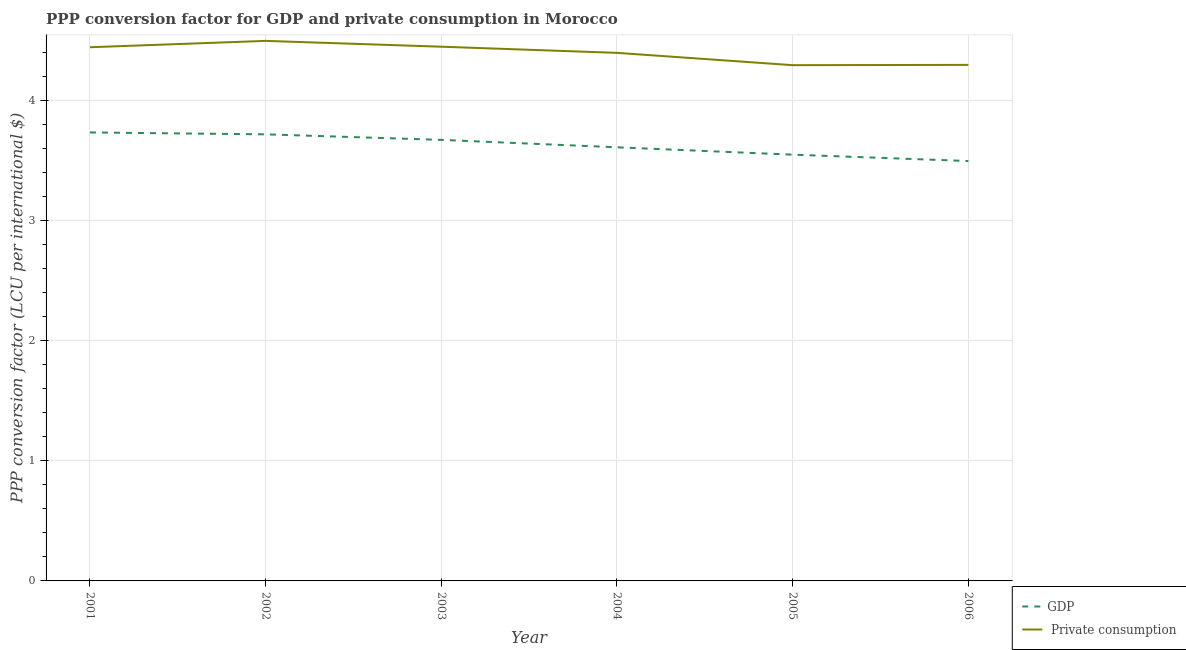How many different coloured lines are there?
Give a very brief answer. 2. Does the line corresponding to ppp conversion factor for private consumption intersect with the line corresponding to ppp conversion factor for gdp?
Offer a terse response. No. Is the number of lines equal to the number of legend labels?
Keep it short and to the point. Yes. What is the ppp conversion factor for private consumption in 2002?
Keep it short and to the point. 4.49. Across all years, what is the maximum ppp conversion factor for private consumption?
Make the answer very short. 4.49. Across all years, what is the minimum ppp conversion factor for private consumption?
Provide a short and direct response. 4.29. In which year was the ppp conversion factor for private consumption maximum?
Offer a very short reply. 2002. What is the total ppp conversion factor for private consumption in the graph?
Make the answer very short. 26.37. What is the difference between the ppp conversion factor for private consumption in 2003 and that in 2004?
Offer a terse response. 0.05. What is the difference between the ppp conversion factor for private consumption in 2004 and the ppp conversion factor for gdp in 2006?
Provide a succinct answer. 0.9. What is the average ppp conversion factor for private consumption per year?
Give a very brief answer. 4.39. In the year 2003, what is the difference between the ppp conversion factor for gdp and ppp conversion factor for private consumption?
Keep it short and to the point. -0.78. What is the ratio of the ppp conversion factor for gdp in 2001 to that in 2006?
Your response must be concise. 1.07. Is the ppp conversion factor for gdp in 2001 less than that in 2003?
Your answer should be very brief. No. Is the difference between the ppp conversion factor for private consumption in 2003 and 2005 greater than the difference between the ppp conversion factor for gdp in 2003 and 2005?
Provide a succinct answer. Yes. What is the difference between the highest and the second highest ppp conversion factor for private consumption?
Your answer should be very brief. 0.05. What is the difference between the highest and the lowest ppp conversion factor for gdp?
Provide a succinct answer. 0.24. Does the ppp conversion factor for private consumption monotonically increase over the years?
Your answer should be very brief. No. What is the difference between two consecutive major ticks on the Y-axis?
Offer a very short reply. 1. Are the values on the major ticks of Y-axis written in scientific E-notation?
Your answer should be compact. No. Does the graph contain any zero values?
Offer a terse response. No. How many legend labels are there?
Provide a succinct answer. 2. How are the legend labels stacked?
Your response must be concise. Vertical. What is the title of the graph?
Your answer should be compact. PPP conversion factor for GDP and private consumption in Morocco. Does "Research and Development" appear as one of the legend labels in the graph?
Keep it short and to the point. No. What is the label or title of the X-axis?
Offer a terse response. Year. What is the label or title of the Y-axis?
Your response must be concise. PPP conversion factor (LCU per international $). What is the PPP conversion factor (LCU per international $) of GDP in 2001?
Keep it short and to the point. 3.73. What is the PPP conversion factor (LCU per international $) in  Private consumption in 2001?
Offer a very short reply. 4.44. What is the PPP conversion factor (LCU per international $) of GDP in 2002?
Your answer should be compact. 3.72. What is the PPP conversion factor (LCU per international $) of  Private consumption in 2002?
Provide a succinct answer. 4.49. What is the PPP conversion factor (LCU per international $) in GDP in 2003?
Offer a terse response. 3.67. What is the PPP conversion factor (LCU per international $) of  Private consumption in 2003?
Your response must be concise. 4.45. What is the PPP conversion factor (LCU per international $) of GDP in 2004?
Provide a succinct answer. 3.61. What is the PPP conversion factor (LCU per international $) of  Private consumption in 2004?
Your answer should be very brief. 4.4. What is the PPP conversion factor (LCU per international $) in GDP in 2005?
Offer a terse response. 3.55. What is the PPP conversion factor (LCU per international $) of  Private consumption in 2005?
Your answer should be very brief. 4.29. What is the PPP conversion factor (LCU per international $) in GDP in 2006?
Ensure brevity in your answer.  3.49. What is the PPP conversion factor (LCU per international $) in  Private consumption in 2006?
Your answer should be very brief. 4.3. Across all years, what is the maximum PPP conversion factor (LCU per international $) in GDP?
Make the answer very short. 3.73. Across all years, what is the maximum PPP conversion factor (LCU per international $) of  Private consumption?
Keep it short and to the point. 4.49. Across all years, what is the minimum PPP conversion factor (LCU per international $) of GDP?
Give a very brief answer. 3.49. Across all years, what is the minimum PPP conversion factor (LCU per international $) of  Private consumption?
Ensure brevity in your answer.  4.29. What is the total PPP conversion factor (LCU per international $) of GDP in the graph?
Make the answer very short. 21.77. What is the total PPP conversion factor (LCU per international $) of  Private consumption in the graph?
Your answer should be very brief. 26.37. What is the difference between the PPP conversion factor (LCU per international $) of GDP in 2001 and that in 2002?
Make the answer very short. 0.02. What is the difference between the PPP conversion factor (LCU per international $) in  Private consumption in 2001 and that in 2002?
Make the answer very short. -0.05. What is the difference between the PPP conversion factor (LCU per international $) in GDP in 2001 and that in 2003?
Make the answer very short. 0.06. What is the difference between the PPP conversion factor (LCU per international $) of  Private consumption in 2001 and that in 2003?
Give a very brief answer. -0. What is the difference between the PPP conversion factor (LCU per international $) of GDP in 2001 and that in 2004?
Keep it short and to the point. 0.12. What is the difference between the PPP conversion factor (LCU per international $) in  Private consumption in 2001 and that in 2004?
Your response must be concise. 0.05. What is the difference between the PPP conversion factor (LCU per international $) in GDP in 2001 and that in 2005?
Provide a succinct answer. 0.18. What is the difference between the PPP conversion factor (LCU per international $) in  Private consumption in 2001 and that in 2005?
Provide a short and direct response. 0.15. What is the difference between the PPP conversion factor (LCU per international $) of GDP in 2001 and that in 2006?
Make the answer very short. 0.24. What is the difference between the PPP conversion factor (LCU per international $) of  Private consumption in 2001 and that in 2006?
Offer a terse response. 0.15. What is the difference between the PPP conversion factor (LCU per international $) of GDP in 2002 and that in 2003?
Provide a short and direct response. 0.05. What is the difference between the PPP conversion factor (LCU per international $) in  Private consumption in 2002 and that in 2003?
Your answer should be very brief. 0.05. What is the difference between the PPP conversion factor (LCU per international $) in GDP in 2002 and that in 2004?
Provide a short and direct response. 0.11. What is the difference between the PPP conversion factor (LCU per international $) in  Private consumption in 2002 and that in 2004?
Provide a short and direct response. 0.1. What is the difference between the PPP conversion factor (LCU per international $) in GDP in 2002 and that in 2005?
Your answer should be compact. 0.17. What is the difference between the PPP conversion factor (LCU per international $) of  Private consumption in 2002 and that in 2005?
Give a very brief answer. 0.2. What is the difference between the PPP conversion factor (LCU per international $) in GDP in 2002 and that in 2006?
Your answer should be very brief. 0.22. What is the difference between the PPP conversion factor (LCU per international $) of  Private consumption in 2002 and that in 2006?
Keep it short and to the point. 0.2. What is the difference between the PPP conversion factor (LCU per international $) in GDP in 2003 and that in 2004?
Your answer should be compact. 0.06. What is the difference between the PPP conversion factor (LCU per international $) in  Private consumption in 2003 and that in 2004?
Provide a short and direct response. 0.05. What is the difference between the PPP conversion factor (LCU per international $) of GDP in 2003 and that in 2005?
Offer a very short reply. 0.12. What is the difference between the PPP conversion factor (LCU per international $) of  Private consumption in 2003 and that in 2005?
Ensure brevity in your answer.  0.15. What is the difference between the PPP conversion factor (LCU per international $) in GDP in 2003 and that in 2006?
Provide a short and direct response. 0.18. What is the difference between the PPP conversion factor (LCU per international $) in  Private consumption in 2003 and that in 2006?
Offer a terse response. 0.15. What is the difference between the PPP conversion factor (LCU per international $) of GDP in 2004 and that in 2005?
Provide a succinct answer. 0.06. What is the difference between the PPP conversion factor (LCU per international $) in  Private consumption in 2004 and that in 2005?
Your answer should be very brief. 0.1. What is the difference between the PPP conversion factor (LCU per international $) of GDP in 2004 and that in 2006?
Offer a very short reply. 0.11. What is the difference between the PPP conversion factor (LCU per international $) of GDP in 2005 and that in 2006?
Ensure brevity in your answer.  0.05. What is the difference between the PPP conversion factor (LCU per international $) in  Private consumption in 2005 and that in 2006?
Give a very brief answer. -0. What is the difference between the PPP conversion factor (LCU per international $) in GDP in 2001 and the PPP conversion factor (LCU per international $) in  Private consumption in 2002?
Provide a succinct answer. -0.76. What is the difference between the PPP conversion factor (LCU per international $) of GDP in 2001 and the PPP conversion factor (LCU per international $) of  Private consumption in 2003?
Offer a terse response. -0.71. What is the difference between the PPP conversion factor (LCU per international $) of GDP in 2001 and the PPP conversion factor (LCU per international $) of  Private consumption in 2004?
Keep it short and to the point. -0.66. What is the difference between the PPP conversion factor (LCU per international $) of GDP in 2001 and the PPP conversion factor (LCU per international $) of  Private consumption in 2005?
Provide a short and direct response. -0.56. What is the difference between the PPP conversion factor (LCU per international $) in GDP in 2001 and the PPP conversion factor (LCU per international $) in  Private consumption in 2006?
Offer a very short reply. -0.56. What is the difference between the PPP conversion factor (LCU per international $) in GDP in 2002 and the PPP conversion factor (LCU per international $) in  Private consumption in 2003?
Give a very brief answer. -0.73. What is the difference between the PPP conversion factor (LCU per international $) in GDP in 2002 and the PPP conversion factor (LCU per international $) in  Private consumption in 2004?
Provide a succinct answer. -0.68. What is the difference between the PPP conversion factor (LCU per international $) in GDP in 2002 and the PPP conversion factor (LCU per international $) in  Private consumption in 2005?
Offer a very short reply. -0.58. What is the difference between the PPP conversion factor (LCU per international $) in GDP in 2002 and the PPP conversion factor (LCU per international $) in  Private consumption in 2006?
Keep it short and to the point. -0.58. What is the difference between the PPP conversion factor (LCU per international $) of GDP in 2003 and the PPP conversion factor (LCU per international $) of  Private consumption in 2004?
Offer a very short reply. -0.72. What is the difference between the PPP conversion factor (LCU per international $) of GDP in 2003 and the PPP conversion factor (LCU per international $) of  Private consumption in 2005?
Your answer should be compact. -0.62. What is the difference between the PPP conversion factor (LCU per international $) in GDP in 2003 and the PPP conversion factor (LCU per international $) in  Private consumption in 2006?
Keep it short and to the point. -0.62. What is the difference between the PPP conversion factor (LCU per international $) of GDP in 2004 and the PPP conversion factor (LCU per international $) of  Private consumption in 2005?
Give a very brief answer. -0.68. What is the difference between the PPP conversion factor (LCU per international $) in GDP in 2004 and the PPP conversion factor (LCU per international $) in  Private consumption in 2006?
Ensure brevity in your answer.  -0.69. What is the difference between the PPP conversion factor (LCU per international $) in GDP in 2005 and the PPP conversion factor (LCU per international $) in  Private consumption in 2006?
Give a very brief answer. -0.75. What is the average PPP conversion factor (LCU per international $) of GDP per year?
Offer a terse response. 3.63. What is the average PPP conversion factor (LCU per international $) in  Private consumption per year?
Your response must be concise. 4.39. In the year 2001, what is the difference between the PPP conversion factor (LCU per international $) in GDP and PPP conversion factor (LCU per international $) in  Private consumption?
Provide a succinct answer. -0.71. In the year 2002, what is the difference between the PPP conversion factor (LCU per international $) of GDP and PPP conversion factor (LCU per international $) of  Private consumption?
Provide a succinct answer. -0.78. In the year 2003, what is the difference between the PPP conversion factor (LCU per international $) in GDP and PPP conversion factor (LCU per international $) in  Private consumption?
Provide a succinct answer. -0.78. In the year 2004, what is the difference between the PPP conversion factor (LCU per international $) of GDP and PPP conversion factor (LCU per international $) of  Private consumption?
Provide a short and direct response. -0.79. In the year 2005, what is the difference between the PPP conversion factor (LCU per international $) of GDP and PPP conversion factor (LCU per international $) of  Private consumption?
Provide a short and direct response. -0.74. In the year 2006, what is the difference between the PPP conversion factor (LCU per international $) in GDP and PPP conversion factor (LCU per international $) in  Private consumption?
Make the answer very short. -0.8. What is the ratio of the PPP conversion factor (LCU per international $) in GDP in 2001 to that in 2002?
Make the answer very short. 1. What is the ratio of the PPP conversion factor (LCU per international $) in  Private consumption in 2001 to that in 2002?
Your response must be concise. 0.99. What is the ratio of the PPP conversion factor (LCU per international $) in GDP in 2001 to that in 2003?
Make the answer very short. 1.02. What is the ratio of the PPP conversion factor (LCU per international $) in  Private consumption in 2001 to that in 2003?
Your answer should be very brief. 1. What is the ratio of the PPP conversion factor (LCU per international $) of GDP in 2001 to that in 2004?
Offer a terse response. 1.03. What is the ratio of the PPP conversion factor (LCU per international $) of  Private consumption in 2001 to that in 2004?
Offer a terse response. 1.01. What is the ratio of the PPP conversion factor (LCU per international $) in GDP in 2001 to that in 2005?
Your answer should be compact. 1.05. What is the ratio of the PPP conversion factor (LCU per international $) in  Private consumption in 2001 to that in 2005?
Make the answer very short. 1.03. What is the ratio of the PPP conversion factor (LCU per international $) of GDP in 2001 to that in 2006?
Offer a very short reply. 1.07. What is the ratio of the PPP conversion factor (LCU per international $) in  Private consumption in 2001 to that in 2006?
Make the answer very short. 1.03. What is the ratio of the PPP conversion factor (LCU per international $) of GDP in 2002 to that in 2003?
Ensure brevity in your answer.  1.01. What is the ratio of the PPP conversion factor (LCU per international $) of  Private consumption in 2002 to that in 2003?
Offer a terse response. 1.01. What is the ratio of the PPP conversion factor (LCU per international $) in GDP in 2002 to that in 2004?
Provide a succinct answer. 1.03. What is the ratio of the PPP conversion factor (LCU per international $) of  Private consumption in 2002 to that in 2004?
Make the answer very short. 1.02. What is the ratio of the PPP conversion factor (LCU per international $) of GDP in 2002 to that in 2005?
Your response must be concise. 1.05. What is the ratio of the PPP conversion factor (LCU per international $) in  Private consumption in 2002 to that in 2005?
Keep it short and to the point. 1.05. What is the ratio of the PPP conversion factor (LCU per international $) of GDP in 2002 to that in 2006?
Provide a succinct answer. 1.06. What is the ratio of the PPP conversion factor (LCU per international $) in  Private consumption in 2002 to that in 2006?
Make the answer very short. 1.05. What is the ratio of the PPP conversion factor (LCU per international $) of GDP in 2003 to that in 2004?
Give a very brief answer. 1.02. What is the ratio of the PPP conversion factor (LCU per international $) of  Private consumption in 2003 to that in 2004?
Your answer should be compact. 1.01. What is the ratio of the PPP conversion factor (LCU per international $) in GDP in 2003 to that in 2005?
Provide a short and direct response. 1.03. What is the ratio of the PPP conversion factor (LCU per international $) in  Private consumption in 2003 to that in 2005?
Your response must be concise. 1.04. What is the ratio of the PPP conversion factor (LCU per international $) of GDP in 2003 to that in 2006?
Ensure brevity in your answer.  1.05. What is the ratio of the PPP conversion factor (LCU per international $) of  Private consumption in 2003 to that in 2006?
Give a very brief answer. 1.04. What is the ratio of the PPP conversion factor (LCU per international $) of GDP in 2004 to that in 2005?
Your response must be concise. 1.02. What is the ratio of the PPP conversion factor (LCU per international $) of  Private consumption in 2004 to that in 2005?
Offer a very short reply. 1.02. What is the ratio of the PPP conversion factor (LCU per international $) of GDP in 2004 to that in 2006?
Make the answer very short. 1.03. What is the ratio of the PPP conversion factor (LCU per international $) of  Private consumption in 2004 to that in 2006?
Provide a short and direct response. 1.02. What is the ratio of the PPP conversion factor (LCU per international $) of GDP in 2005 to that in 2006?
Your answer should be very brief. 1.02. What is the ratio of the PPP conversion factor (LCU per international $) of  Private consumption in 2005 to that in 2006?
Keep it short and to the point. 1. What is the difference between the highest and the second highest PPP conversion factor (LCU per international $) of GDP?
Provide a short and direct response. 0.02. What is the difference between the highest and the second highest PPP conversion factor (LCU per international $) in  Private consumption?
Keep it short and to the point. 0.05. What is the difference between the highest and the lowest PPP conversion factor (LCU per international $) of GDP?
Make the answer very short. 0.24. What is the difference between the highest and the lowest PPP conversion factor (LCU per international $) of  Private consumption?
Your answer should be compact. 0.2. 